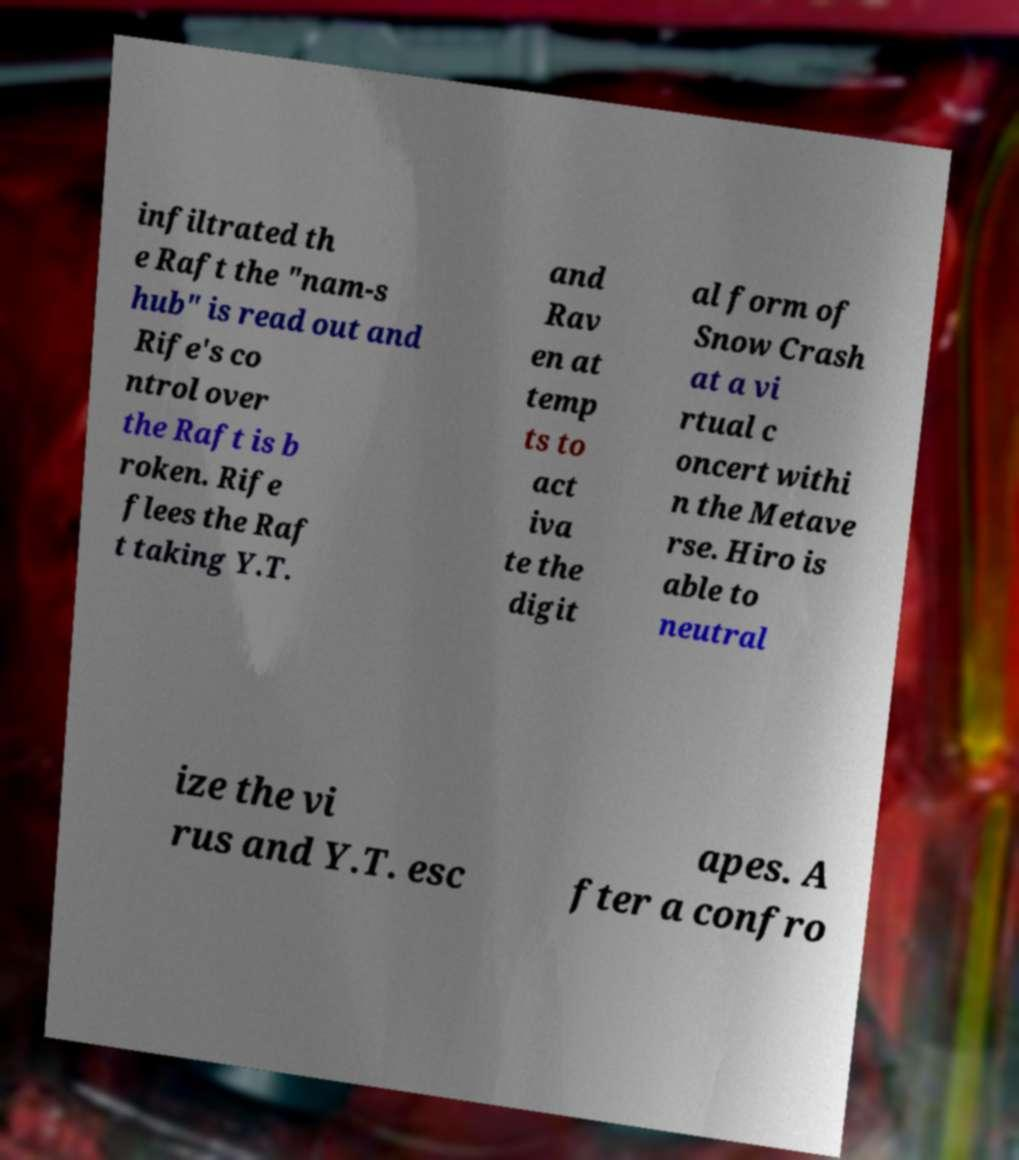For documentation purposes, I need the text within this image transcribed. Could you provide that? infiltrated th e Raft the "nam-s hub" is read out and Rife's co ntrol over the Raft is b roken. Rife flees the Raf t taking Y.T. and Rav en at temp ts to act iva te the digit al form of Snow Crash at a vi rtual c oncert withi n the Metave rse. Hiro is able to neutral ize the vi rus and Y.T. esc apes. A fter a confro 